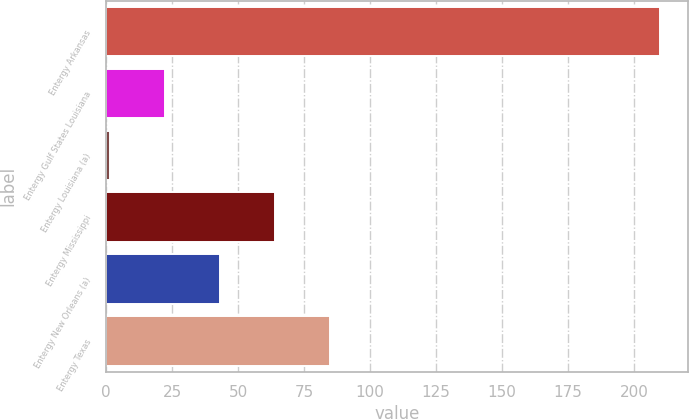<chart> <loc_0><loc_0><loc_500><loc_500><bar_chart><fcel>Entergy Arkansas<fcel>Entergy Gulf States Louisiana<fcel>Entergy Louisiana (a)<fcel>Entergy Mississippi<fcel>Entergy New Orleans (a)<fcel>Entergy Texas<nl><fcel>209.8<fcel>22.33<fcel>1.5<fcel>63.99<fcel>43.16<fcel>84.82<nl></chart> 